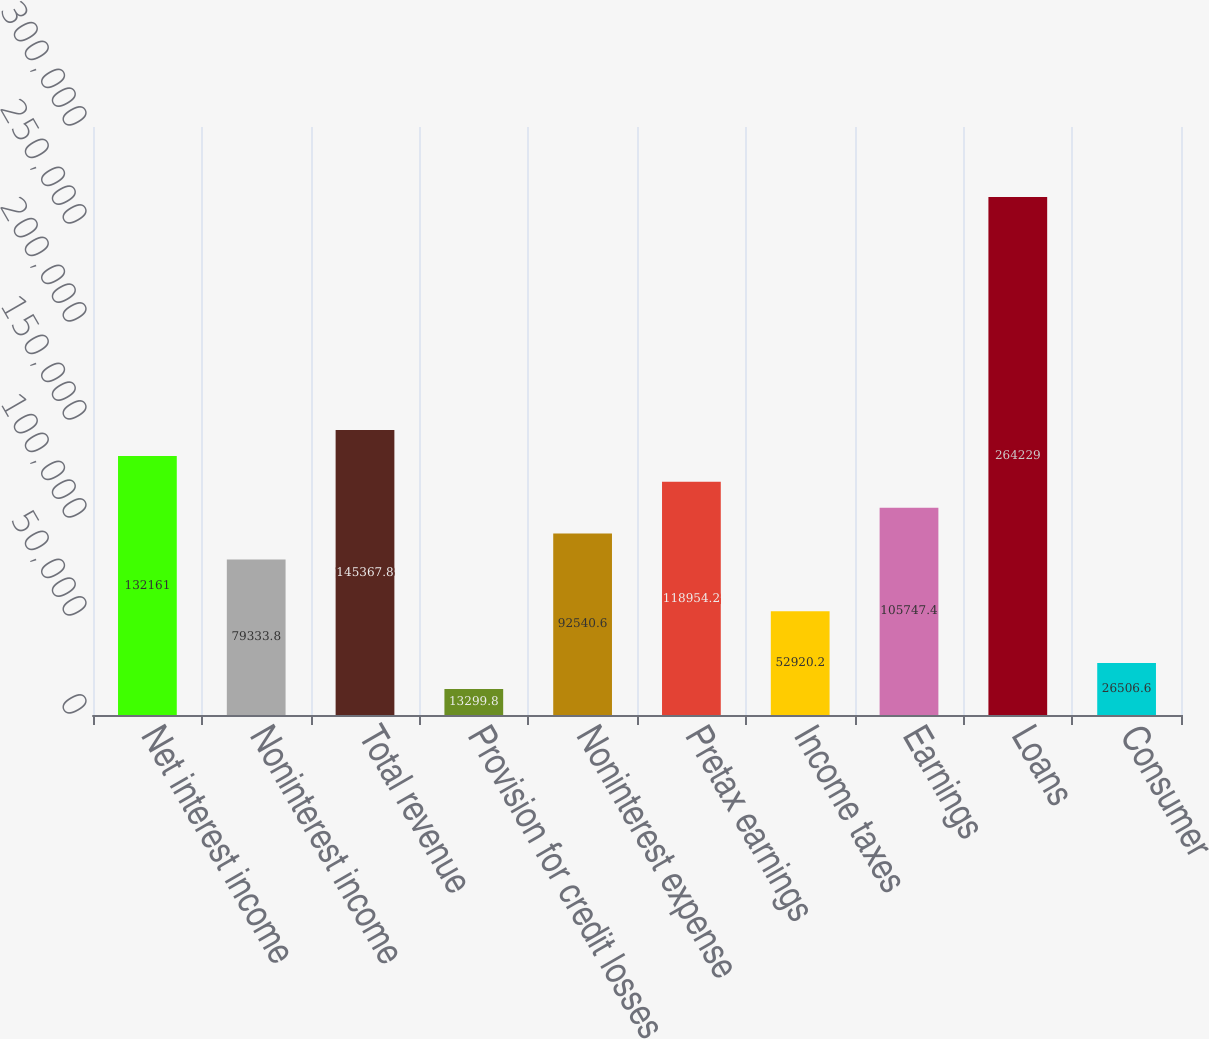Convert chart. <chart><loc_0><loc_0><loc_500><loc_500><bar_chart><fcel>Net interest income<fcel>Noninterest income<fcel>Total revenue<fcel>Provision for credit losses<fcel>Noninterest expense<fcel>Pretax earnings<fcel>Income taxes<fcel>Earnings<fcel>Loans<fcel>Consumer<nl><fcel>132161<fcel>79333.8<fcel>145368<fcel>13299.8<fcel>92540.6<fcel>118954<fcel>52920.2<fcel>105747<fcel>264229<fcel>26506.6<nl></chart> 